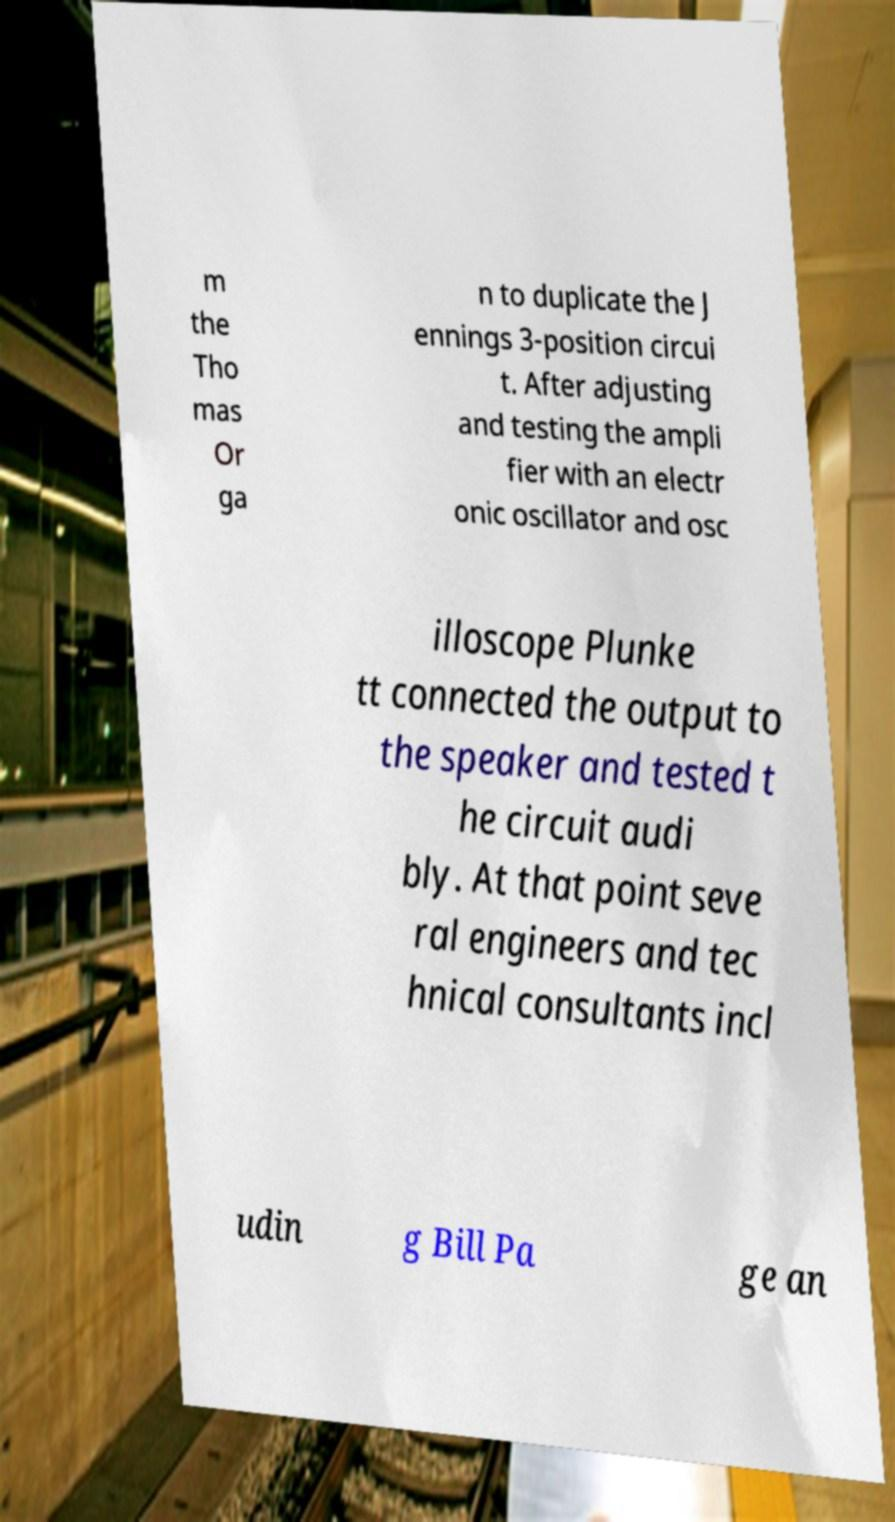Can you accurately transcribe the text from the provided image for me? m the Tho mas Or ga n to duplicate the J ennings 3-position circui t. After adjusting and testing the ampli fier with an electr onic oscillator and osc illoscope Plunke tt connected the output to the speaker and tested t he circuit audi bly. At that point seve ral engineers and tec hnical consultants incl udin g Bill Pa ge an 